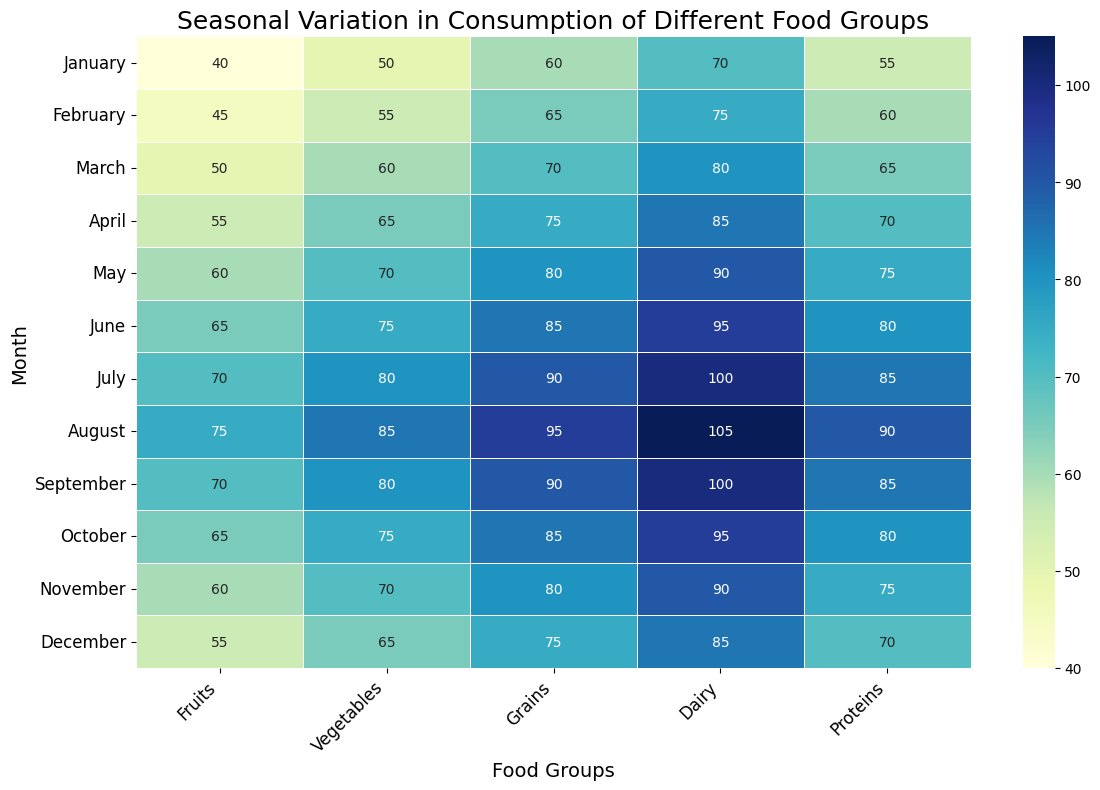What month has the highest consumption of dairy? By looking at the Dairy column in the heatmap, we can see that the value is highest in August for Dairy, which is 105.
Answer: August Which two months have equal consumption of fruits and what months are they? By examining the Fruits row in the heatmap, we see that the values for July and September are both 70. Therefore, these two months have equal consumption of fruits.
Answer: July and September What is the average consumption of proteins in the first quarter (January to March)? To find the average, we sum the Protein values for January, February, and March: 55 + 60 + 65 = 180. Then, we divide by the number of months, which is 3: 180 / 3 = 60.
Answer: 60 Is vegetable consumption in October greater than in November? The heatmap indicates that the vegetable value for October is 75 and for November it is 70. Since 75 is greater than 70, vegetable consumption in October is indeed greater than in November.
Answer: Yes Which food group shows the overall highest value in the heatmap and what is that value? By examining the heatmap, we see that the highest value across all food groups is 105. This value is found in the Dairy column for the month of August.
Answer: Dairy, 105 How much more vegetables were consumed in August as compared to March? From the heatmap, the vegetable consumption in August is 85 and in March it is 60. The difference is 85 - 60 = 25.
Answer: 25 What is the total consumption of grains from January to June? We sum the Grain values for January to June: 60 + 65 + 70 + 75 + 80 + 85 = 435.
Answer: 435 Does fruit consumption increase steadily from January to August? By inspecting the Fruit row from January to August in the heatmap, we can see the values are: 40, 45, 50, 55, 60, 65, 70, 75. These numbers do increase steadily.
Answer: Yes Which month shows the lowest consumption of proteins? Looking at the Protein column across all months, January has the lowest value at 55.
Answer: January 